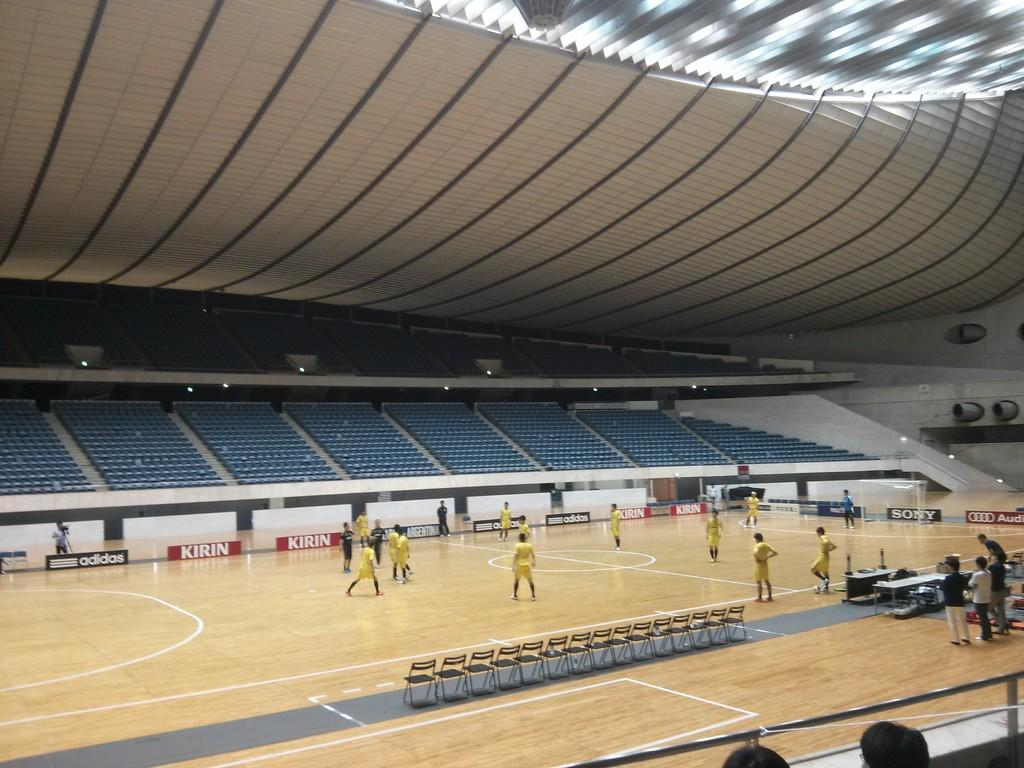What are the people in the image doing? The persons in the image are on the floor. What type of furniture is present in the image? There are chairs and tables in the image. What other objects can be seen in the image? There are boards and lights in the image. Where is the location of the image? The location is described as a roof. What type of growth can be seen on the chairs in the image? There is no growth visible on the chairs in the image. What type of string is used to hang the lights in the image? There is no information about the type of string used to hang the lights in the image. 